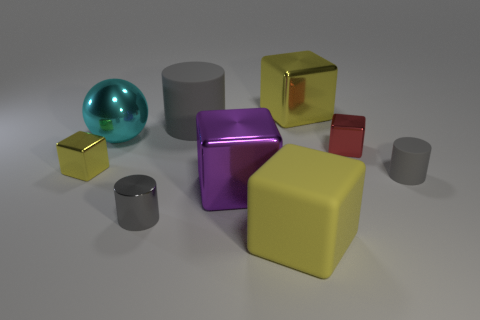There is a tiny shiny object that is right of the shiny thing that is behind the large metal ball; what shape is it?
Your response must be concise. Cube. There is a cyan shiny object; does it have the same size as the yellow object left of the gray metal object?
Keep it short and to the point. No. How big is the cylinder that is in front of the gray matte object in front of the tiny metal cube to the left of the tiny red object?
Provide a succinct answer. Small. What number of things are either gray objects that are in front of the red block or purple things?
Your response must be concise. 3. How many large yellow rubber cubes are behind the tiny gray cylinder that is to the left of the yellow matte thing?
Your answer should be compact. 0. Are there more big rubber things that are behind the big yellow matte cube than big blue objects?
Ensure brevity in your answer.  Yes. There is a matte thing that is on the left side of the tiny red block and behind the yellow rubber block; how big is it?
Provide a short and direct response. Large. The yellow object that is both right of the cyan thing and in front of the big cyan sphere has what shape?
Your response must be concise. Cube. There is a yellow metallic thing on the left side of the big shiny block that is right of the yellow matte cube; is there a yellow matte cube that is left of it?
Your response must be concise. No. What number of objects are either rubber cylinders on the right side of the large gray thing or big cubes behind the small yellow thing?
Make the answer very short. 2. 